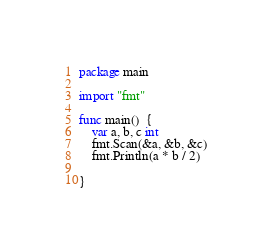<code> <loc_0><loc_0><loc_500><loc_500><_Go_>package main

import "fmt"

func main()  {
	var a, b, c int
	fmt.Scan(&a, &b, &c)
	fmt.Println(a * b / 2)

}</code> 